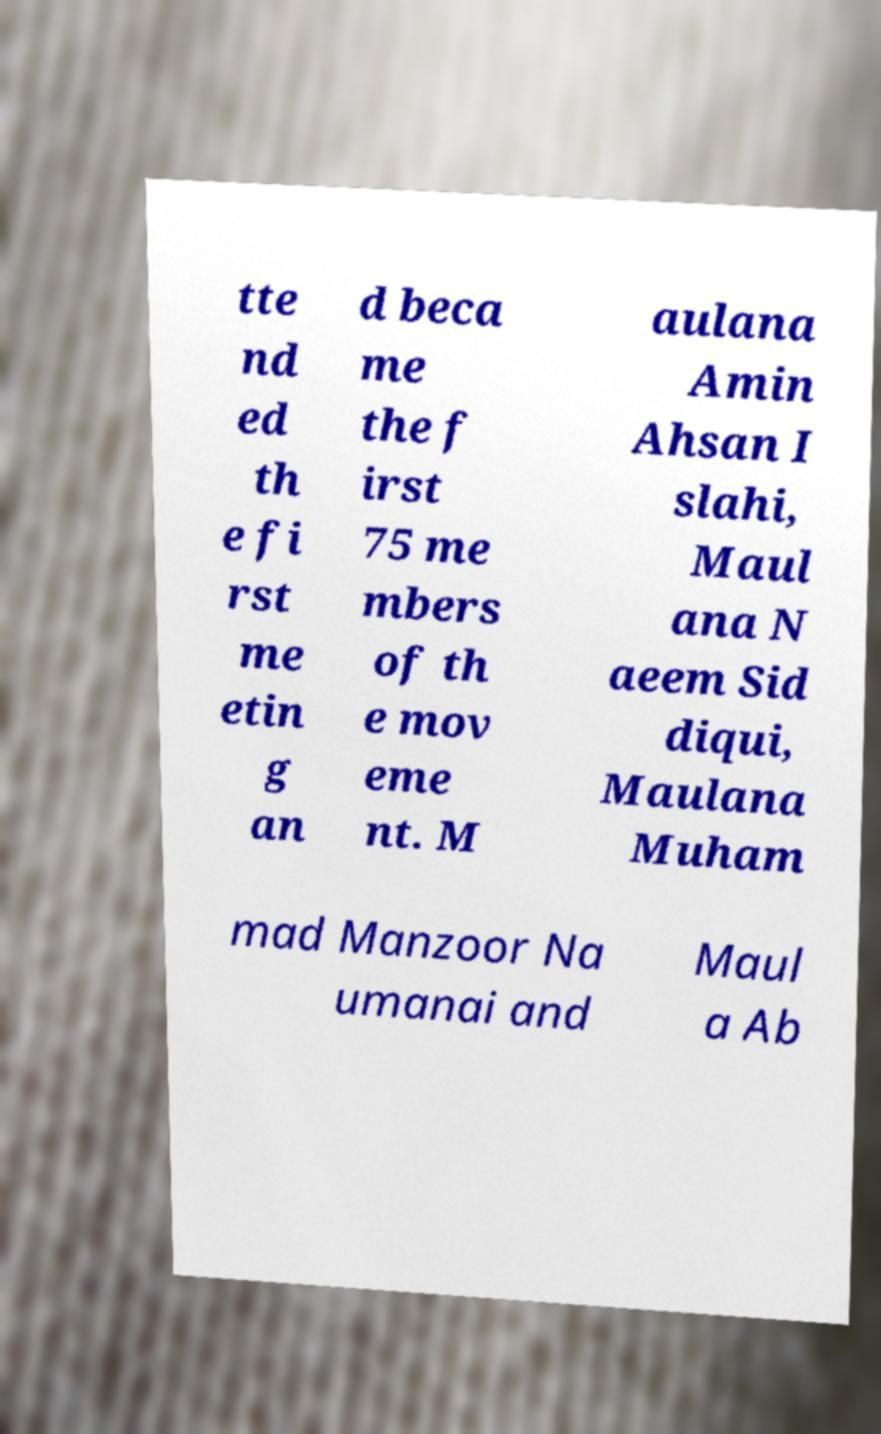Please identify and transcribe the text found in this image. tte nd ed th e fi rst me etin g an d beca me the f irst 75 me mbers of th e mov eme nt. M aulana Amin Ahsan I slahi, Maul ana N aeem Sid diqui, Maulana Muham mad Manzoor Na umanai and Maul a Ab 